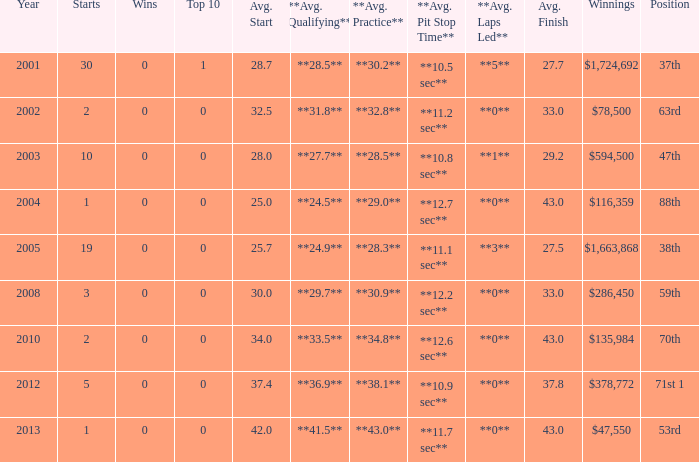How many starts for an average finish greater than 43? None. 